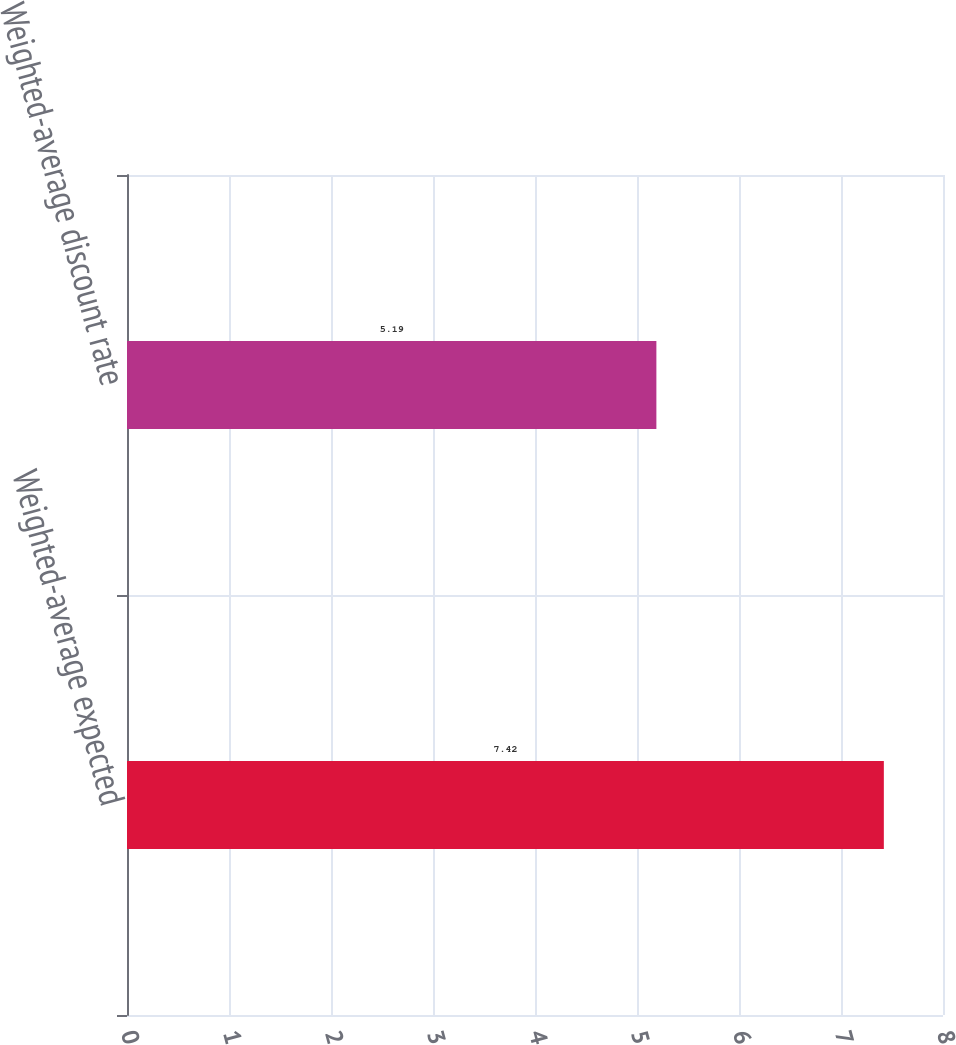<chart> <loc_0><loc_0><loc_500><loc_500><bar_chart><fcel>Weighted-average expected<fcel>Weighted-average discount rate<nl><fcel>7.42<fcel>5.19<nl></chart> 